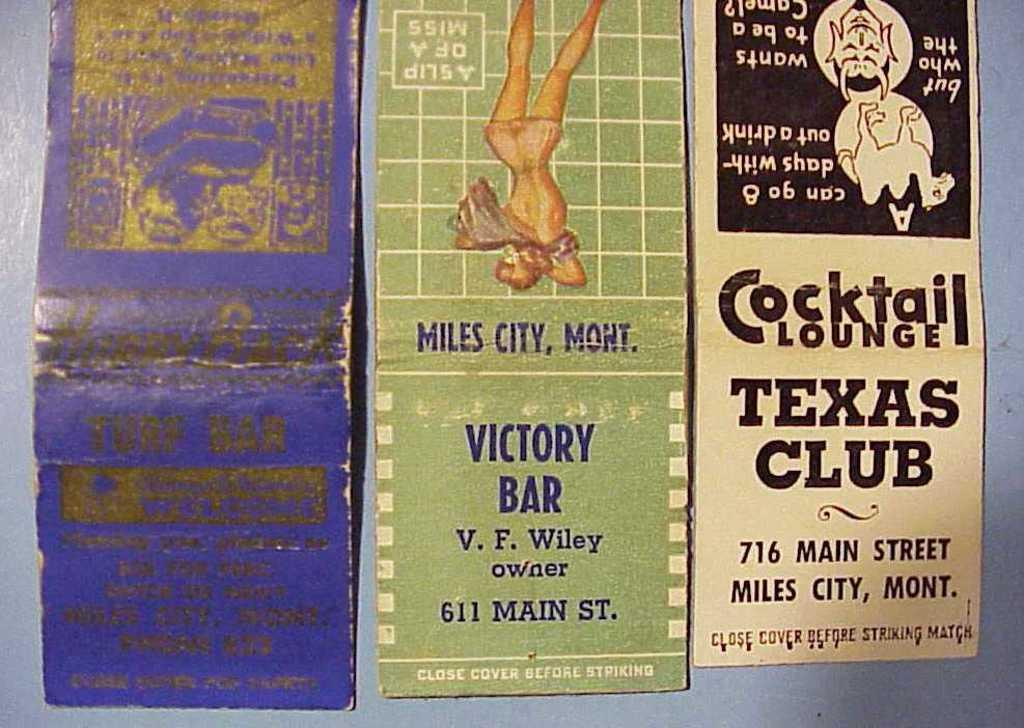Provide a one-sentence caption for the provided image. Matchbooks are advertising places in Miles City, Montana. 